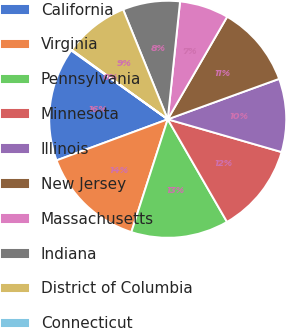Convert chart. <chart><loc_0><loc_0><loc_500><loc_500><pie_chart><fcel>California<fcel>Virginia<fcel>Pennsylvania<fcel>Minnesota<fcel>Illinois<fcel>New Jersey<fcel>Massachusetts<fcel>Indiana<fcel>District of Columbia<fcel>Connecticut<nl><fcel>15.5%<fcel>14.4%<fcel>13.3%<fcel>12.2%<fcel>10.0%<fcel>11.1%<fcel>6.7%<fcel>7.8%<fcel>8.9%<fcel>0.09%<nl></chart> 